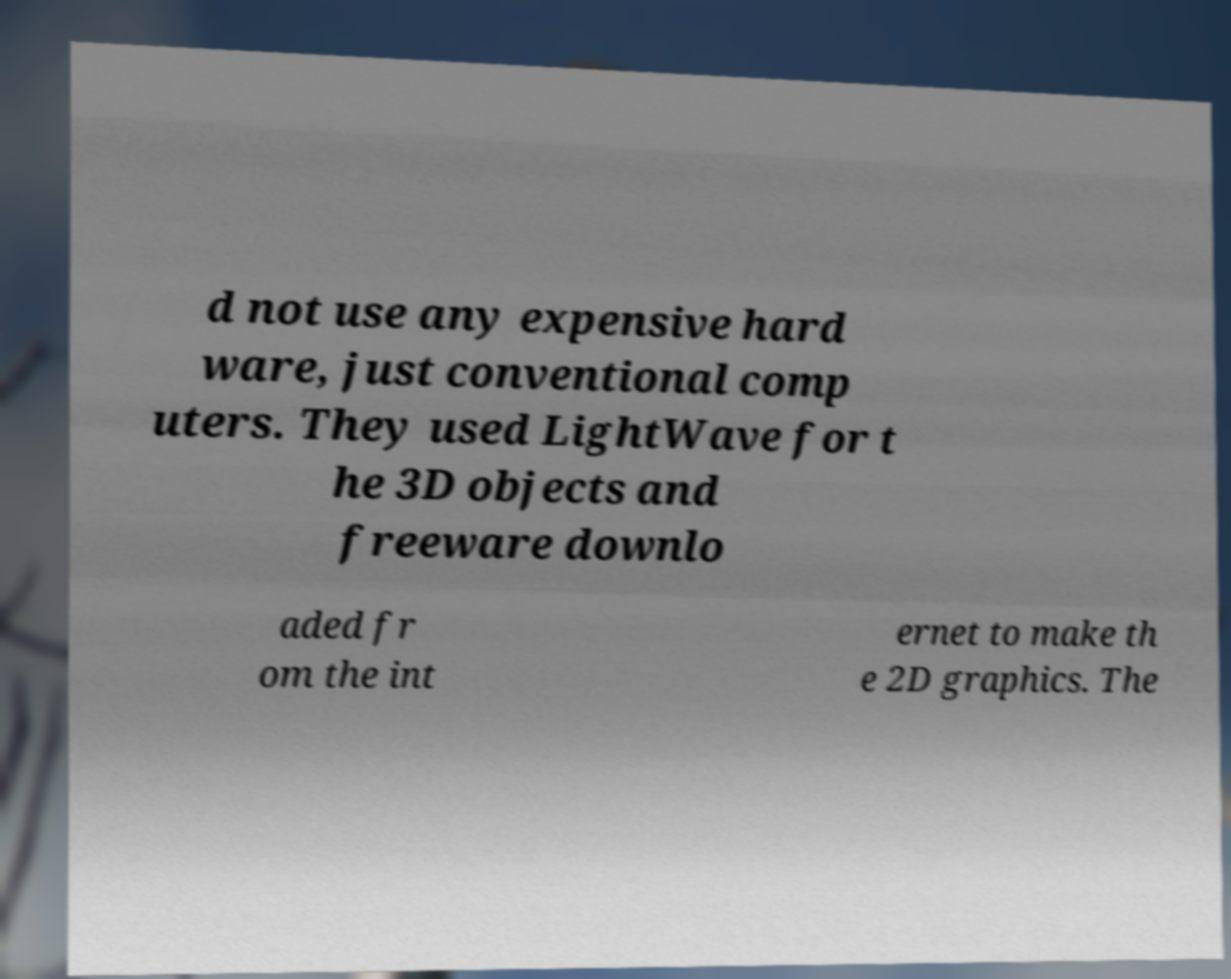There's text embedded in this image that I need extracted. Can you transcribe it verbatim? d not use any expensive hard ware, just conventional comp uters. They used LightWave for t he 3D objects and freeware downlo aded fr om the int ernet to make th e 2D graphics. The 